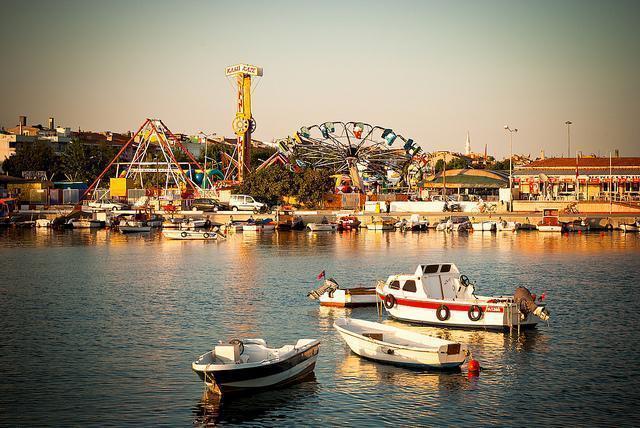Where can you see a similar scene to what is happening behind the boats?
Choose the correct response, then elucidate: 'Answer: answer
Rationale: rationale.'
Options: Parking garage, king kullen, six flags, costco. Answer: six flags.
Rationale: This location also has amusement park and carnival rides like the ones on the shore. 